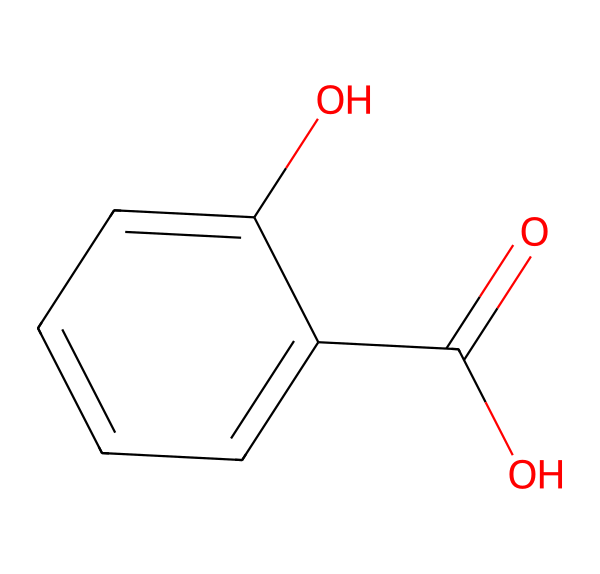What is the molecular formula of salicylic acid? By analyzing the SMILES representation, we can identify the distinct atoms present. The structure contains 7 carbon atoms (C), 6 hydrogen atoms (H), and 3 oxygen atoms (O). Thus, combining these counts gives us the molecular formula C7H6O3.
Answer: C7H6O3 How many aromatic rings are present in salicylic acid? In the provided structure, the benzene ring is recognized as an aromatic ring. There is one such ring indicated in the chemical representation of salicylic acid.
Answer: 1 What functional groups are present in salicylic acid? By examining the structure, we can identify two functional groups: a carboxylic acid (-COOH) group and a hydroxyl (-OH) group attached to the aromatic ring.
Answer: carboxylic acid and hydroxyl Why does salicylic acid have anti-inflammatory properties? Salicylic acid belongs to the class of beta hydroxy acids (BHAs), which are known for their anti-inflammatory properties due to their ability to exfoliate the skin and penetrate pores. The represented hydroxyl group contributes to these properties.
Answer: exfoliation How does salicylic acid help treat acne? Salicylic acid helps treat acne by penetrating deep into the pores to dissolve oil and dead skin cells, effectively preventing clogged pores. Its chemical structure allows it to exhibit properties that promote the shedding of the outer layer of skin cells.
Answer: unclogs pores Which part of salicylic acid contributes to its ability to derive from willow bark? The carboxylic acid group (-COOH) is directly associated with the natural derivation from willow bark, as it is the source of salicylic acid. The presence of this group in the structure confirms its natural origin.
Answer: carboxylic acid group 